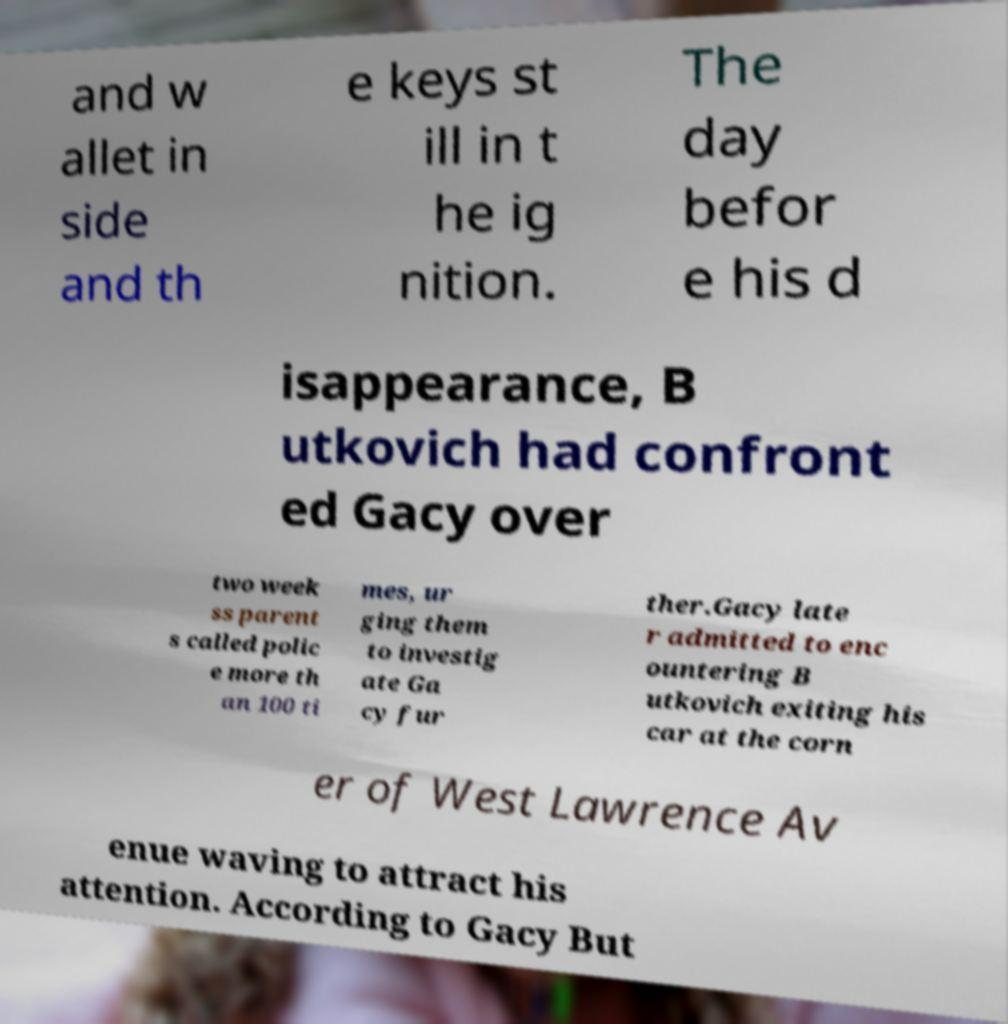Can you accurately transcribe the text from the provided image for me? and w allet in side and th e keys st ill in t he ig nition. The day befor e his d isappearance, B utkovich had confront ed Gacy over two week ss parent s called polic e more th an 100 ti mes, ur ging them to investig ate Ga cy fur ther.Gacy late r admitted to enc ountering B utkovich exiting his car at the corn er of West Lawrence Av enue waving to attract his attention. According to Gacy But 